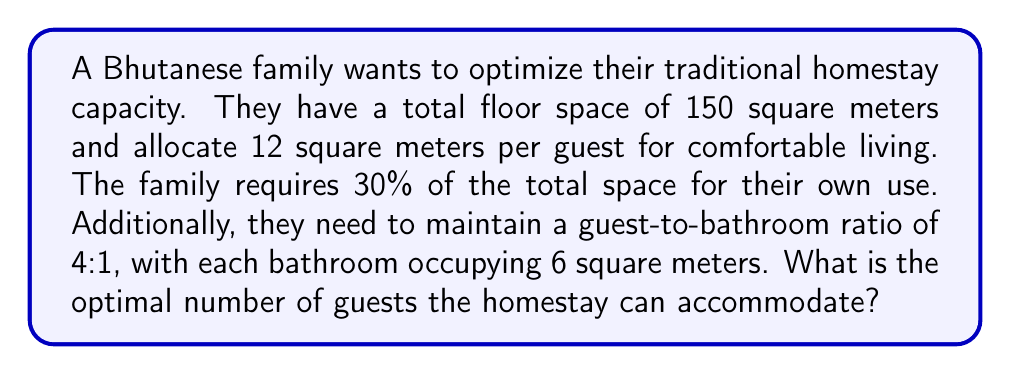Provide a solution to this math problem. Let's approach this problem step-by-step:

1) First, calculate the available space for guests:
   Total space = 150 m²
   Family space = 30% of 150 m² = 0.3 × 150 m² = 45 m²
   Available guest space = 150 m² - 45 m² = 105 m²

2) Let $x$ be the number of guests. We need to account for both guest living space and bathroom space:
   Guest living space: $12x$ m²
   Number of bathrooms needed: $\frac{x}{4}$
   Bathroom space: $6 \times \frac{x}{4} = \frac{3x}{2}$ m²

3) Set up an inequality:
   Total guest space ≤ Available guest space
   $12x + \frac{3x}{2} \leq 105$

4) Simplify the inequality:
   $12x + \frac{3x}{2} \leq 105$
   $24x + 3x \leq 210$
   $27x \leq 210$

5) Solve for $x$:
   $x \leq \frac{210}{27} \approx 7.78$

6) Since we can't have a fractional number of guests, we round down to the nearest whole number.
Answer: 7 guests 